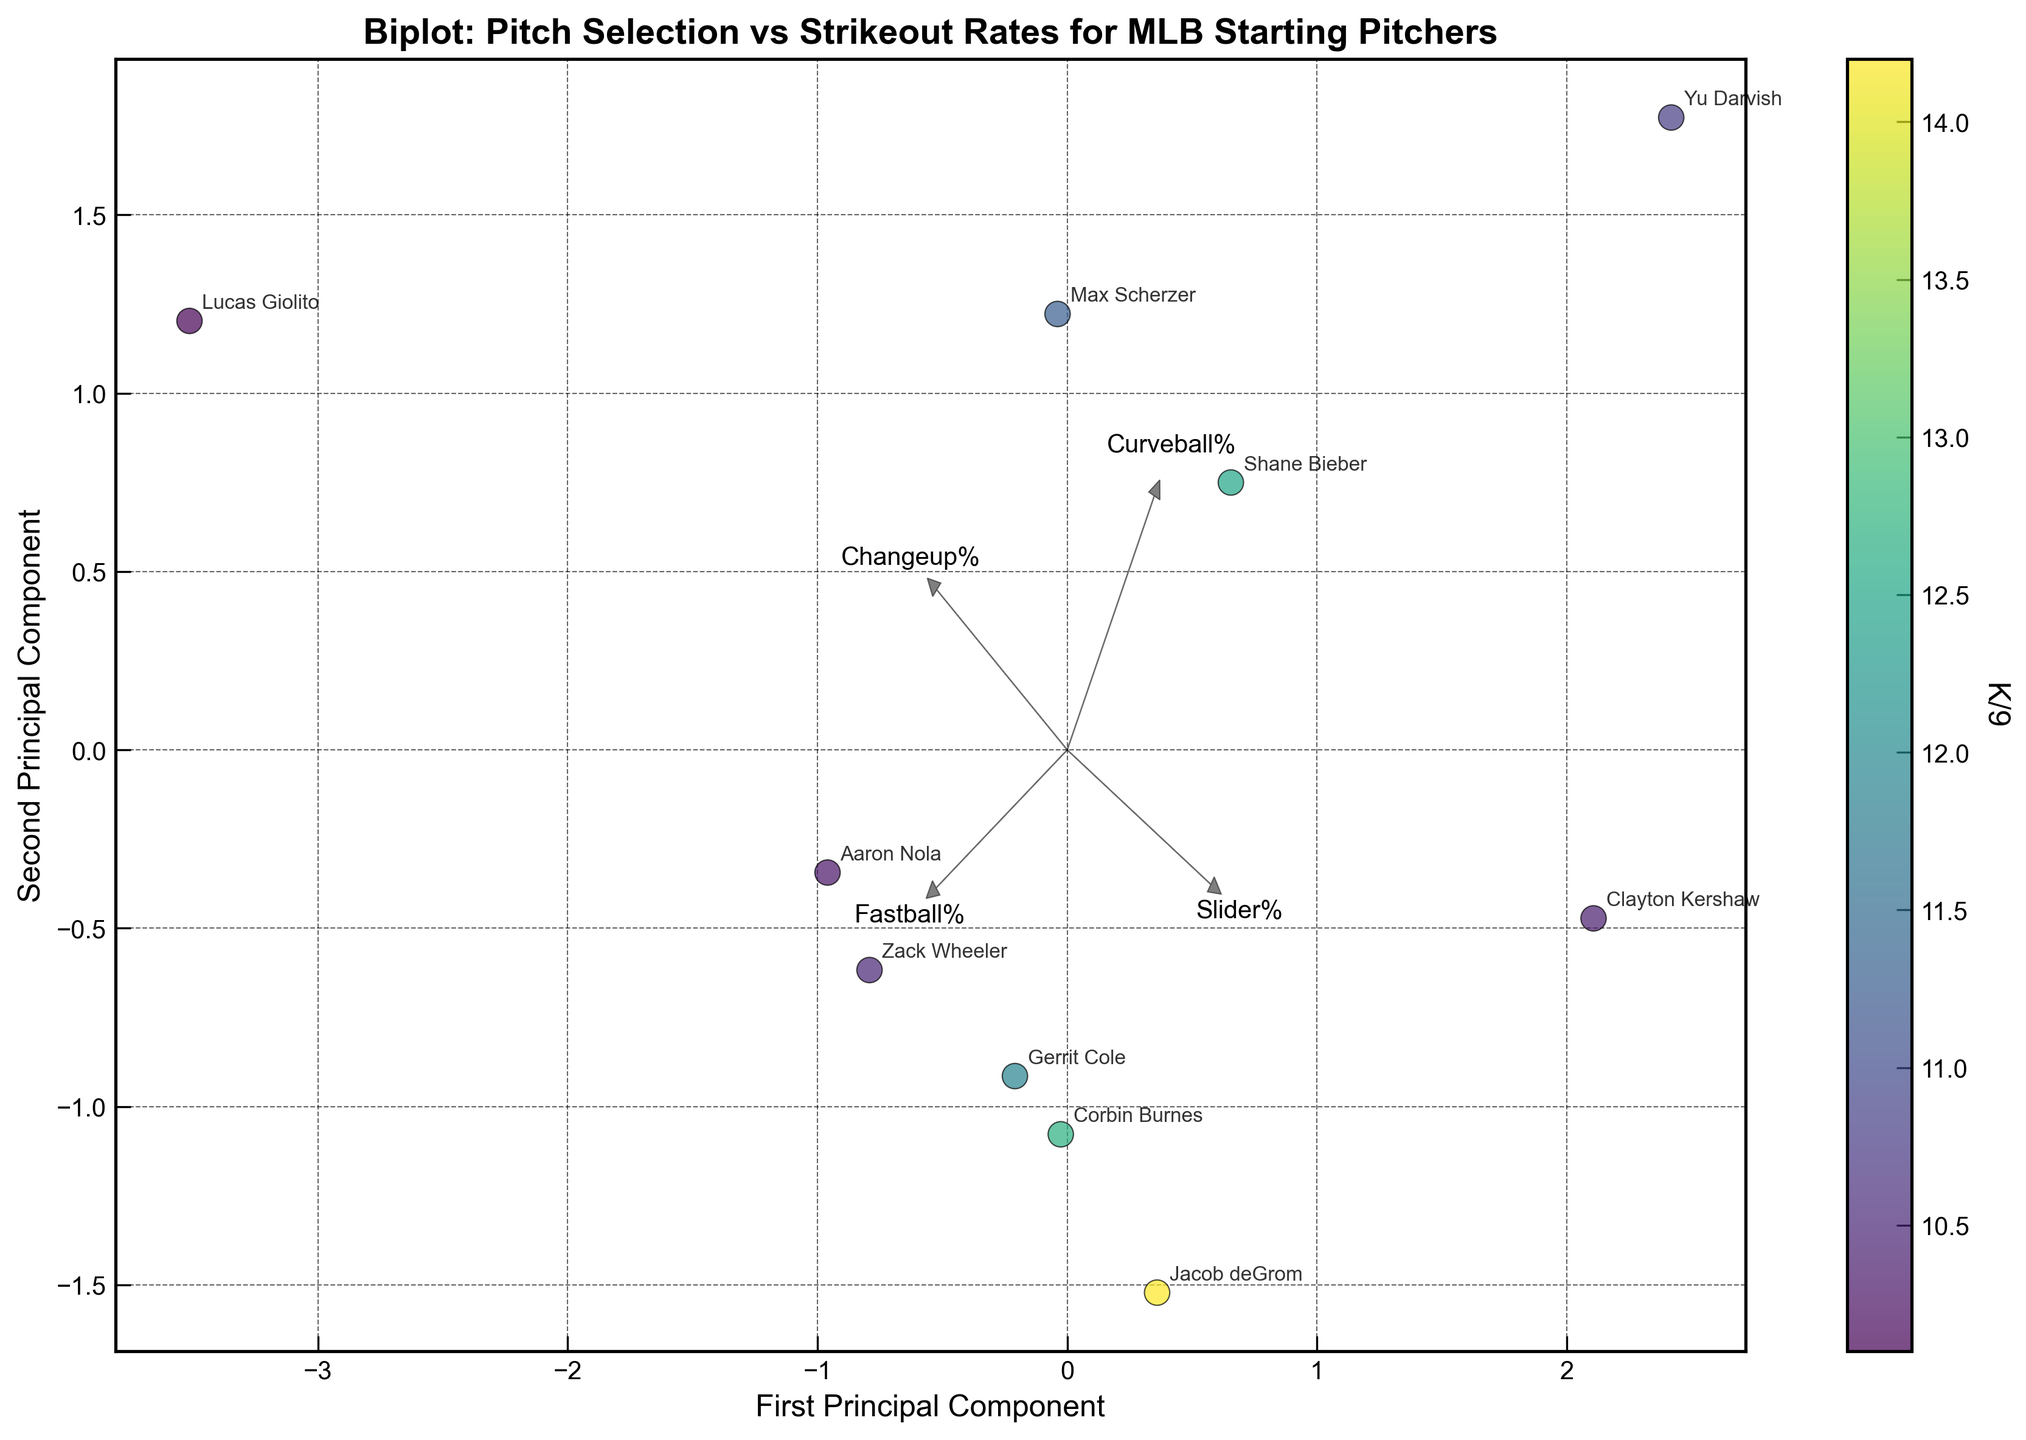What's the title of the plot? The title of the plot can be found at the top of the image. It is usually displayed in a larger and bolder font.
Answer: Biplot: Pitch Selection vs Strikeout Rates for MLB Starting Pitchers How many principal components are represented in the figure? The figure shows a 2D representation, so it includes two principal components, which can be confirmed by the two axes labeled "First Principal Component" and "Second Principal Component".
Answer: 2 Which pitcher has the highest K/9 rate? To find the pitcher with the highest strikeouts per nine innings (K/9), locate the data point with the darkest color, according to the colorbar. The label next to this point identifies the pitcher.
Answer: Jacob deGrom What are the labels on the x and y axes? The axis labels indicate what each principal component represents. These labels are found near the respective axes.
Answer: First Principal Component and Second Principal Component Which pitch type is most strongly associated with the First Principal Component? Look at the arrows that represent pitch types and see which one aligns closest with the x-axis. The pitch type whose arrow points furthest in the direction of the first principal component is the one most strongly associated with it.
Answer: Slider% Which two pitchers have the most similar pitch selection profiles according to the biplot? Compare the positions of the pitchers on the plot. The two pitchers whose data points are closest to each other have the most similar profiles.
Answer: Gerrit Cole and Zack Wheeler Which feature vector points most directly downward in the plot? To find the feature vector pointing downward, look for the arrow pointing toward the lower part of the y-axis. The text label on this arrow identifies the corresponding pitch type.
Answer: Changeup% Is there any pitcher whose data point is located close to the origin? The origin is the point (0,0) on the plot. Identify the data point closest to this origin.
Answer: Aaron Nola Which principal component explains the most variance in the data? Although the exact variance percentages aren't given in the figure, typically the first principal component explains more variance than the second. This is why it's shown on the x-axis.
Answer: First Principal Component 